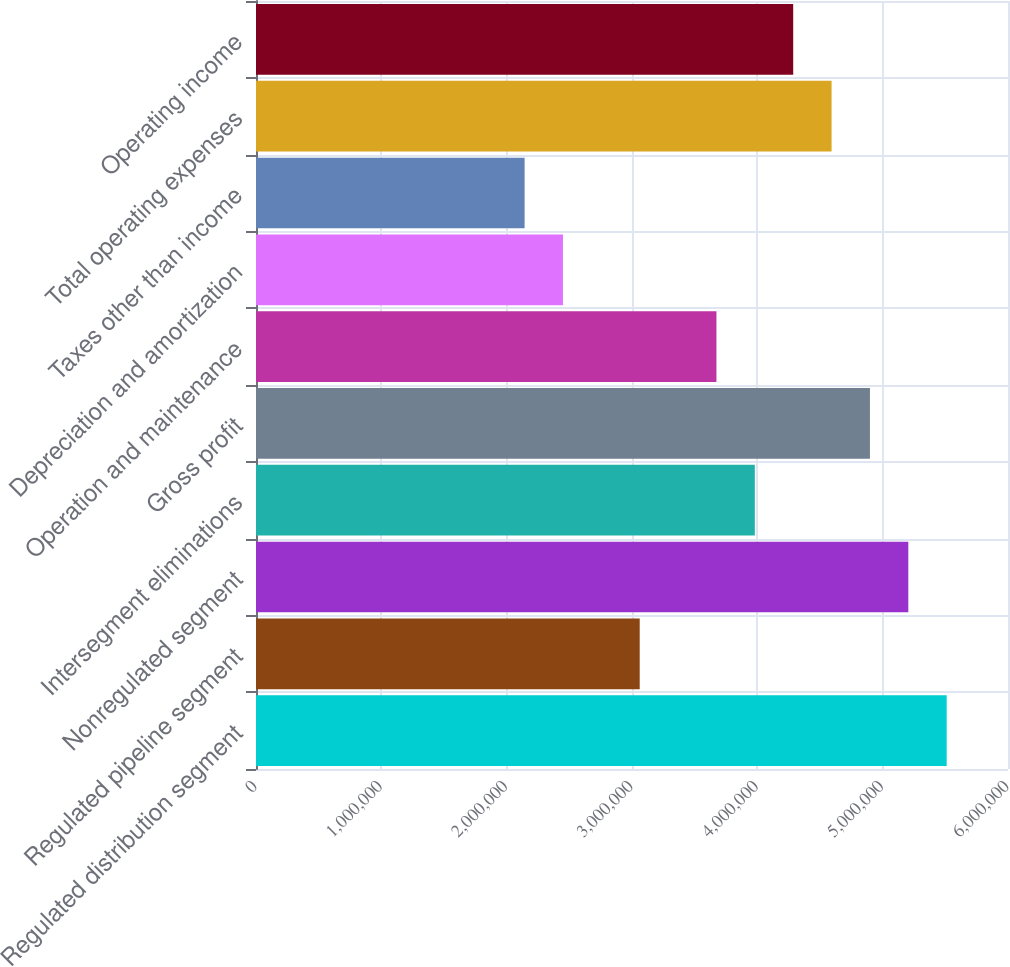<chart> <loc_0><loc_0><loc_500><loc_500><bar_chart><fcel>Regulated distribution segment<fcel>Regulated pipeline segment<fcel>Nonregulated segment<fcel>Intersegment eliminations<fcel>Gross profit<fcel>Operation and maintenance<fcel>Depreciation and amortization<fcel>Taxes other than income<fcel>Total operating expenses<fcel>Operating income<nl><fcel>5.51078e+06<fcel>3.06155e+06<fcel>5.20463e+06<fcel>3.98001e+06<fcel>4.89847e+06<fcel>3.67385e+06<fcel>2.44924e+06<fcel>2.14308e+06<fcel>4.59232e+06<fcel>4.28616e+06<nl></chart> 